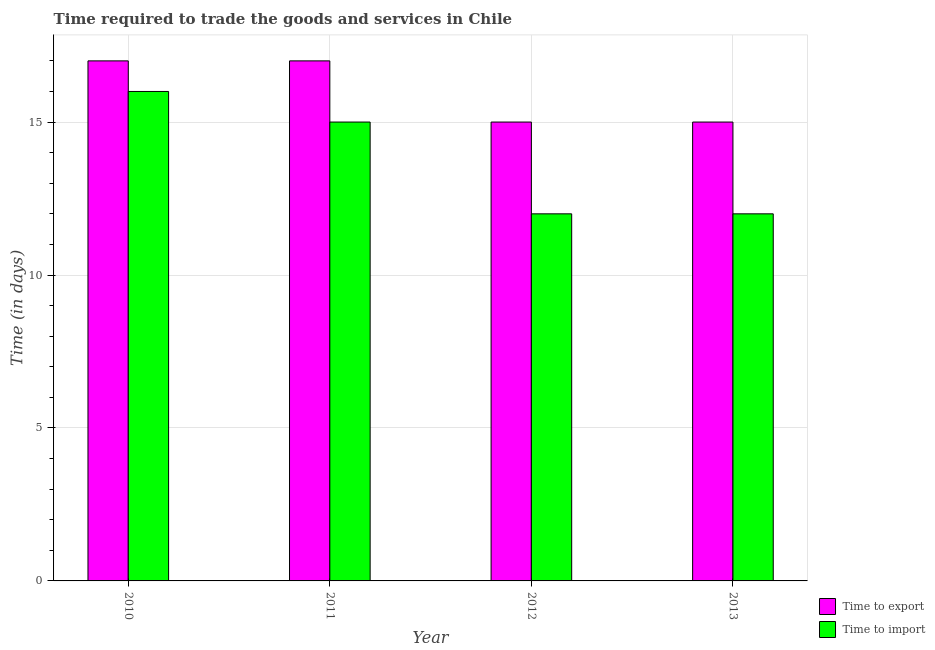Are the number of bars on each tick of the X-axis equal?
Give a very brief answer. Yes. How many bars are there on the 4th tick from the left?
Make the answer very short. 2. What is the time to import in 2010?
Your answer should be very brief. 16. Across all years, what is the maximum time to export?
Your answer should be compact. 17. Across all years, what is the minimum time to import?
Give a very brief answer. 12. In which year was the time to import maximum?
Provide a short and direct response. 2010. In which year was the time to import minimum?
Provide a short and direct response. 2012. What is the total time to export in the graph?
Provide a short and direct response. 64. What is the difference between the time to export in 2011 and the time to import in 2010?
Offer a very short reply. 0. What is the average time to import per year?
Provide a succinct answer. 13.75. In the year 2011, what is the difference between the time to import and time to export?
Give a very brief answer. 0. In how many years, is the time to export greater than 8 days?
Keep it short and to the point. 4. What is the ratio of the time to import in 2010 to that in 2013?
Ensure brevity in your answer.  1.33. Is the difference between the time to import in 2010 and 2013 greater than the difference between the time to export in 2010 and 2013?
Offer a terse response. No. What is the difference between the highest and the second highest time to import?
Give a very brief answer. 1. What is the difference between the highest and the lowest time to import?
Provide a succinct answer. 4. What does the 1st bar from the left in 2013 represents?
Keep it short and to the point. Time to export. What does the 1st bar from the right in 2012 represents?
Provide a succinct answer. Time to import. Are all the bars in the graph horizontal?
Provide a short and direct response. No. How many years are there in the graph?
Ensure brevity in your answer.  4. Does the graph contain grids?
Give a very brief answer. Yes. Where does the legend appear in the graph?
Your answer should be compact. Bottom right. What is the title of the graph?
Offer a very short reply. Time required to trade the goods and services in Chile. Does "Rural Population" appear as one of the legend labels in the graph?
Provide a succinct answer. No. What is the label or title of the X-axis?
Provide a succinct answer. Year. What is the label or title of the Y-axis?
Offer a very short reply. Time (in days). What is the Time (in days) in Time to export in 2011?
Make the answer very short. 17. What is the Time (in days) of Time to import in 2011?
Your answer should be compact. 15. What is the Time (in days) of Time to export in 2012?
Ensure brevity in your answer.  15. What is the Time (in days) of Time to import in 2012?
Provide a short and direct response. 12. Across all years, what is the maximum Time (in days) in Time to import?
Provide a short and direct response. 16. What is the total Time (in days) of Time to import in the graph?
Your response must be concise. 55. What is the difference between the Time (in days) in Time to import in 2011 and that in 2013?
Give a very brief answer. 3. What is the difference between the Time (in days) in Time to export in 2010 and the Time (in days) in Time to import in 2012?
Your response must be concise. 5. What is the difference between the Time (in days) of Time to export in 2010 and the Time (in days) of Time to import in 2013?
Keep it short and to the point. 5. What is the difference between the Time (in days) in Time to export in 2011 and the Time (in days) in Time to import in 2012?
Make the answer very short. 5. What is the difference between the Time (in days) in Time to export in 2012 and the Time (in days) in Time to import in 2013?
Make the answer very short. 3. What is the average Time (in days) of Time to import per year?
Provide a short and direct response. 13.75. What is the ratio of the Time (in days) of Time to export in 2010 to that in 2011?
Keep it short and to the point. 1. What is the ratio of the Time (in days) in Time to import in 2010 to that in 2011?
Your answer should be very brief. 1.07. What is the ratio of the Time (in days) in Time to export in 2010 to that in 2012?
Offer a terse response. 1.13. What is the ratio of the Time (in days) of Time to export in 2010 to that in 2013?
Your answer should be compact. 1.13. What is the ratio of the Time (in days) of Time to import in 2010 to that in 2013?
Make the answer very short. 1.33. What is the ratio of the Time (in days) of Time to export in 2011 to that in 2012?
Make the answer very short. 1.13. What is the ratio of the Time (in days) of Time to import in 2011 to that in 2012?
Your response must be concise. 1.25. What is the ratio of the Time (in days) in Time to export in 2011 to that in 2013?
Provide a short and direct response. 1.13. What is the ratio of the Time (in days) in Time to import in 2011 to that in 2013?
Give a very brief answer. 1.25. What is the ratio of the Time (in days) in Time to export in 2012 to that in 2013?
Your answer should be very brief. 1. What is the difference between the highest and the second highest Time (in days) of Time to export?
Make the answer very short. 0. What is the difference between the highest and the lowest Time (in days) of Time to export?
Provide a succinct answer. 2. 